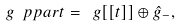Convert formula to latex. <formula><loc_0><loc_0><loc_500><loc_500>\ g \ p p a r t = \ g [ [ t ] ] \oplus \hat { g } _ { - } ,</formula> 